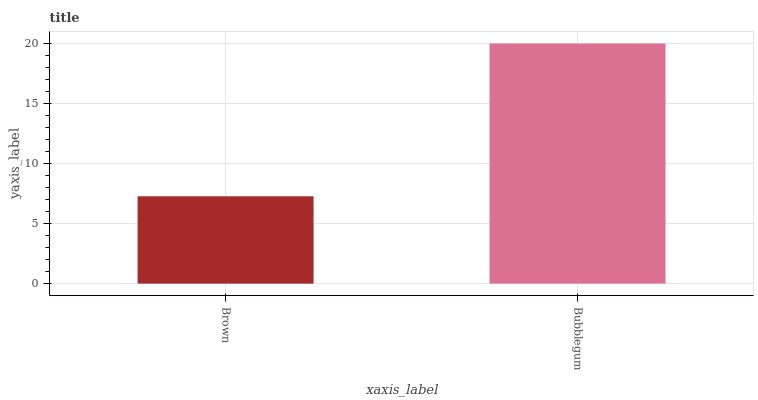Is Brown the minimum?
Answer yes or no. Yes. Is Bubblegum the maximum?
Answer yes or no. Yes. Is Bubblegum the minimum?
Answer yes or no. No. Is Bubblegum greater than Brown?
Answer yes or no. Yes. Is Brown less than Bubblegum?
Answer yes or no. Yes. Is Brown greater than Bubblegum?
Answer yes or no. No. Is Bubblegum less than Brown?
Answer yes or no. No. Is Bubblegum the high median?
Answer yes or no. Yes. Is Brown the low median?
Answer yes or no. Yes. Is Brown the high median?
Answer yes or no. No. Is Bubblegum the low median?
Answer yes or no. No. 